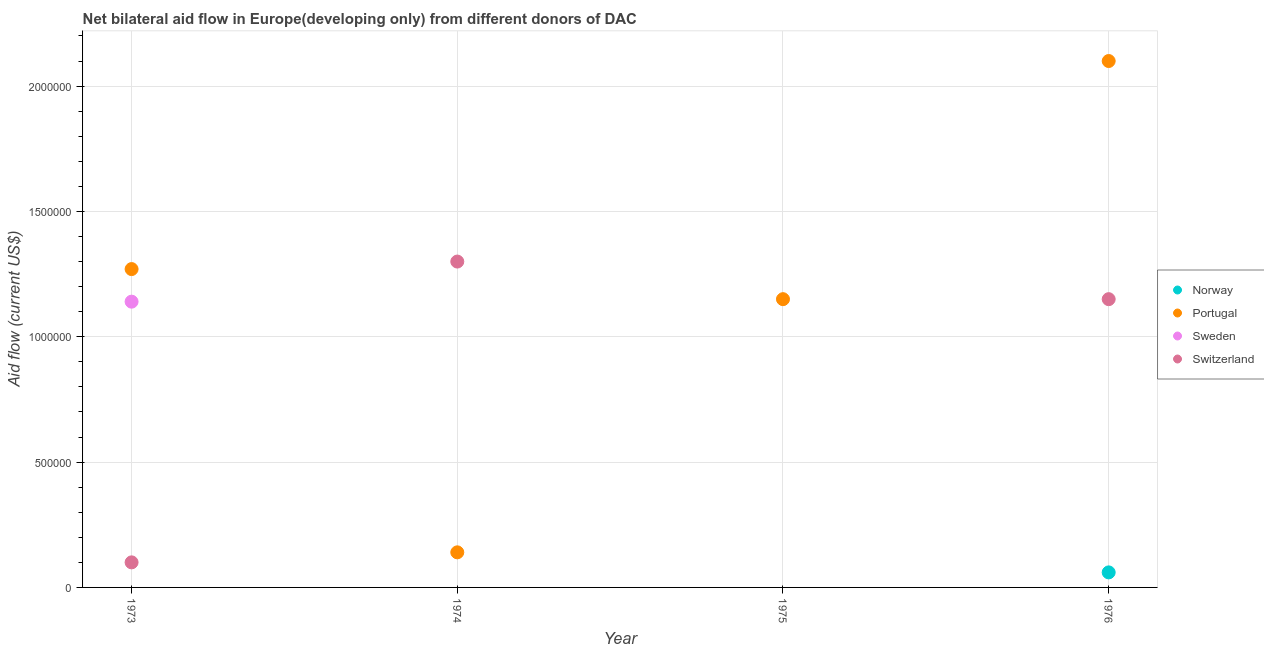What is the amount of aid given by switzerland in 1974?
Make the answer very short. 1.30e+06. Across all years, what is the maximum amount of aid given by norway?
Your answer should be very brief. 6.00e+04. Across all years, what is the minimum amount of aid given by sweden?
Offer a very short reply. 0. In which year was the amount of aid given by portugal maximum?
Ensure brevity in your answer.  1976. What is the total amount of aid given by norway in the graph?
Offer a terse response. 6.00e+04. What is the difference between the amount of aid given by portugal in 1973 and that in 1975?
Offer a very short reply. 1.20e+05. What is the difference between the amount of aid given by portugal in 1976 and the amount of aid given by sweden in 1973?
Your answer should be very brief. 9.60e+05. What is the average amount of aid given by norway per year?
Offer a terse response. 1.50e+04. In the year 1973, what is the difference between the amount of aid given by portugal and amount of aid given by switzerland?
Provide a succinct answer. 1.17e+06. What is the ratio of the amount of aid given by portugal in 1975 to that in 1976?
Offer a very short reply. 0.55. What is the difference between the highest and the second highest amount of aid given by portugal?
Offer a terse response. 8.30e+05. What is the difference between the highest and the lowest amount of aid given by portugal?
Offer a very short reply. 1.96e+06. In how many years, is the amount of aid given by switzerland greater than the average amount of aid given by switzerland taken over all years?
Give a very brief answer. 2. Is it the case that in every year, the sum of the amount of aid given by switzerland and amount of aid given by sweden is greater than the sum of amount of aid given by norway and amount of aid given by portugal?
Offer a very short reply. No. Is the amount of aid given by norway strictly greater than the amount of aid given by portugal over the years?
Provide a succinct answer. No. Is the amount of aid given by sweden strictly less than the amount of aid given by portugal over the years?
Offer a very short reply. Yes. How many dotlines are there?
Your answer should be compact. 4. How many years are there in the graph?
Give a very brief answer. 4. What is the difference between two consecutive major ticks on the Y-axis?
Keep it short and to the point. 5.00e+05. Does the graph contain any zero values?
Provide a succinct answer. Yes. How many legend labels are there?
Offer a terse response. 4. What is the title of the graph?
Your answer should be compact. Net bilateral aid flow in Europe(developing only) from different donors of DAC. What is the label or title of the Y-axis?
Provide a short and direct response. Aid flow (current US$). What is the Aid flow (current US$) of Norway in 1973?
Your answer should be compact. 0. What is the Aid flow (current US$) of Portugal in 1973?
Your answer should be very brief. 1.27e+06. What is the Aid flow (current US$) in Sweden in 1973?
Offer a very short reply. 1.14e+06. What is the Aid flow (current US$) of Switzerland in 1973?
Provide a short and direct response. 1.00e+05. What is the Aid flow (current US$) in Norway in 1974?
Give a very brief answer. 0. What is the Aid flow (current US$) in Switzerland in 1974?
Your answer should be compact. 1.30e+06. What is the Aid flow (current US$) of Portugal in 1975?
Give a very brief answer. 1.15e+06. What is the Aid flow (current US$) of Switzerland in 1975?
Make the answer very short. 0. What is the Aid flow (current US$) of Norway in 1976?
Ensure brevity in your answer.  6.00e+04. What is the Aid flow (current US$) in Portugal in 1976?
Your answer should be compact. 2.10e+06. What is the Aid flow (current US$) in Switzerland in 1976?
Offer a terse response. 1.15e+06. Across all years, what is the maximum Aid flow (current US$) of Portugal?
Offer a very short reply. 2.10e+06. Across all years, what is the maximum Aid flow (current US$) of Sweden?
Offer a very short reply. 1.14e+06. Across all years, what is the maximum Aid flow (current US$) in Switzerland?
Ensure brevity in your answer.  1.30e+06. What is the total Aid flow (current US$) in Norway in the graph?
Give a very brief answer. 6.00e+04. What is the total Aid flow (current US$) of Portugal in the graph?
Ensure brevity in your answer.  4.66e+06. What is the total Aid flow (current US$) in Sweden in the graph?
Your answer should be compact. 1.14e+06. What is the total Aid flow (current US$) of Switzerland in the graph?
Provide a succinct answer. 2.55e+06. What is the difference between the Aid flow (current US$) in Portugal in 1973 and that in 1974?
Make the answer very short. 1.13e+06. What is the difference between the Aid flow (current US$) in Switzerland in 1973 and that in 1974?
Ensure brevity in your answer.  -1.20e+06. What is the difference between the Aid flow (current US$) of Portugal in 1973 and that in 1975?
Your answer should be very brief. 1.20e+05. What is the difference between the Aid flow (current US$) in Portugal in 1973 and that in 1976?
Offer a very short reply. -8.30e+05. What is the difference between the Aid flow (current US$) in Switzerland in 1973 and that in 1976?
Offer a terse response. -1.05e+06. What is the difference between the Aid flow (current US$) in Portugal in 1974 and that in 1975?
Your response must be concise. -1.01e+06. What is the difference between the Aid flow (current US$) of Portugal in 1974 and that in 1976?
Your answer should be very brief. -1.96e+06. What is the difference between the Aid flow (current US$) in Portugal in 1975 and that in 1976?
Offer a terse response. -9.50e+05. What is the difference between the Aid flow (current US$) of Sweden in 1973 and the Aid flow (current US$) of Switzerland in 1976?
Make the answer very short. -10000. What is the difference between the Aid flow (current US$) of Portugal in 1974 and the Aid flow (current US$) of Switzerland in 1976?
Your response must be concise. -1.01e+06. What is the average Aid flow (current US$) of Norway per year?
Offer a very short reply. 1.50e+04. What is the average Aid flow (current US$) in Portugal per year?
Your answer should be very brief. 1.16e+06. What is the average Aid flow (current US$) in Sweden per year?
Provide a succinct answer. 2.85e+05. What is the average Aid flow (current US$) of Switzerland per year?
Make the answer very short. 6.38e+05. In the year 1973, what is the difference between the Aid flow (current US$) of Portugal and Aid flow (current US$) of Switzerland?
Offer a very short reply. 1.17e+06. In the year 1973, what is the difference between the Aid flow (current US$) of Sweden and Aid flow (current US$) of Switzerland?
Provide a succinct answer. 1.04e+06. In the year 1974, what is the difference between the Aid flow (current US$) in Portugal and Aid flow (current US$) in Switzerland?
Ensure brevity in your answer.  -1.16e+06. In the year 1976, what is the difference between the Aid flow (current US$) in Norway and Aid flow (current US$) in Portugal?
Provide a succinct answer. -2.04e+06. In the year 1976, what is the difference between the Aid flow (current US$) in Norway and Aid flow (current US$) in Switzerland?
Provide a succinct answer. -1.09e+06. In the year 1976, what is the difference between the Aid flow (current US$) in Portugal and Aid flow (current US$) in Switzerland?
Make the answer very short. 9.50e+05. What is the ratio of the Aid flow (current US$) of Portugal in 1973 to that in 1974?
Provide a succinct answer. 9.07. What is the ratio of the Aid flow (current US$) of Switzerland in 1973 to that in 1974?
Make the answer very short. 0.08. What is the ratio of the Aid flow (current US$) in Portugal in 1973 to that in 1975?
Give a very brief answer. 1.1. What is the ratio of the Aid flow (current US$) in Portugal in 1973 to that in 1976?
Your answer should be very brief. 0.6. What is the ratio of the Aid flow (current US$) in Switzerland in 1973 to that in 1976?
Offer a very short reply. 0.09. What is the ratio of the Aid flow (current US$) of Portugal in 1974 to that in 1975?
Your answer should be very brief. 0.12. What is the ratio of the Aid flow (current US$) of Portugal in 1974 to that in 1976?
Your response must be concise. 0.07. What is the ratio of the Aid flow (current US$) in Switzerland in 1974 to that in 1976?
Make the answer very short. 1.13. What is the ratio of the Aid flow (current US$) of Portugal in 1975 to that in 1976?
Offer a very short reply. 0.55. What is the difference between the highest and the second highest Aid flow (current US$) in Portugal?
Ensure brevity in your answer.  8.30e+05. What is the difference between the highest and the lowest Aid flow (current US$) of Norway?
Ensure brevity in your answer.  6.00e+04. What is the difference between the highest and the lowest Aid flow (current US$) of Portugal?
Give a very brief answer. 1.96e+06. What is the difference between the highest and the lowest Aid flow (current US$) in Sweden?
Make the answer very short. 1.14e+06. What is the difference between the highest and the lowest Aid flow (current US$) of Switzerland?
Keep it short and to the point. 1.30e+06. 